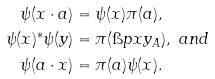Convert formula to latex. <formula><loc_0><loc_0><loc_500><loc_500>\psi ( x \cdot a ) & = \psi ( x ) \pi ( a ) , \\ \psi ( x ) ^ { * } \psi ( y ) & = \pi ( \i p x y _ { A } ) , \ a n d \\ \psi ( a \cdot x ) & = \pi ( a ) \psi ( x ) .</formula> 